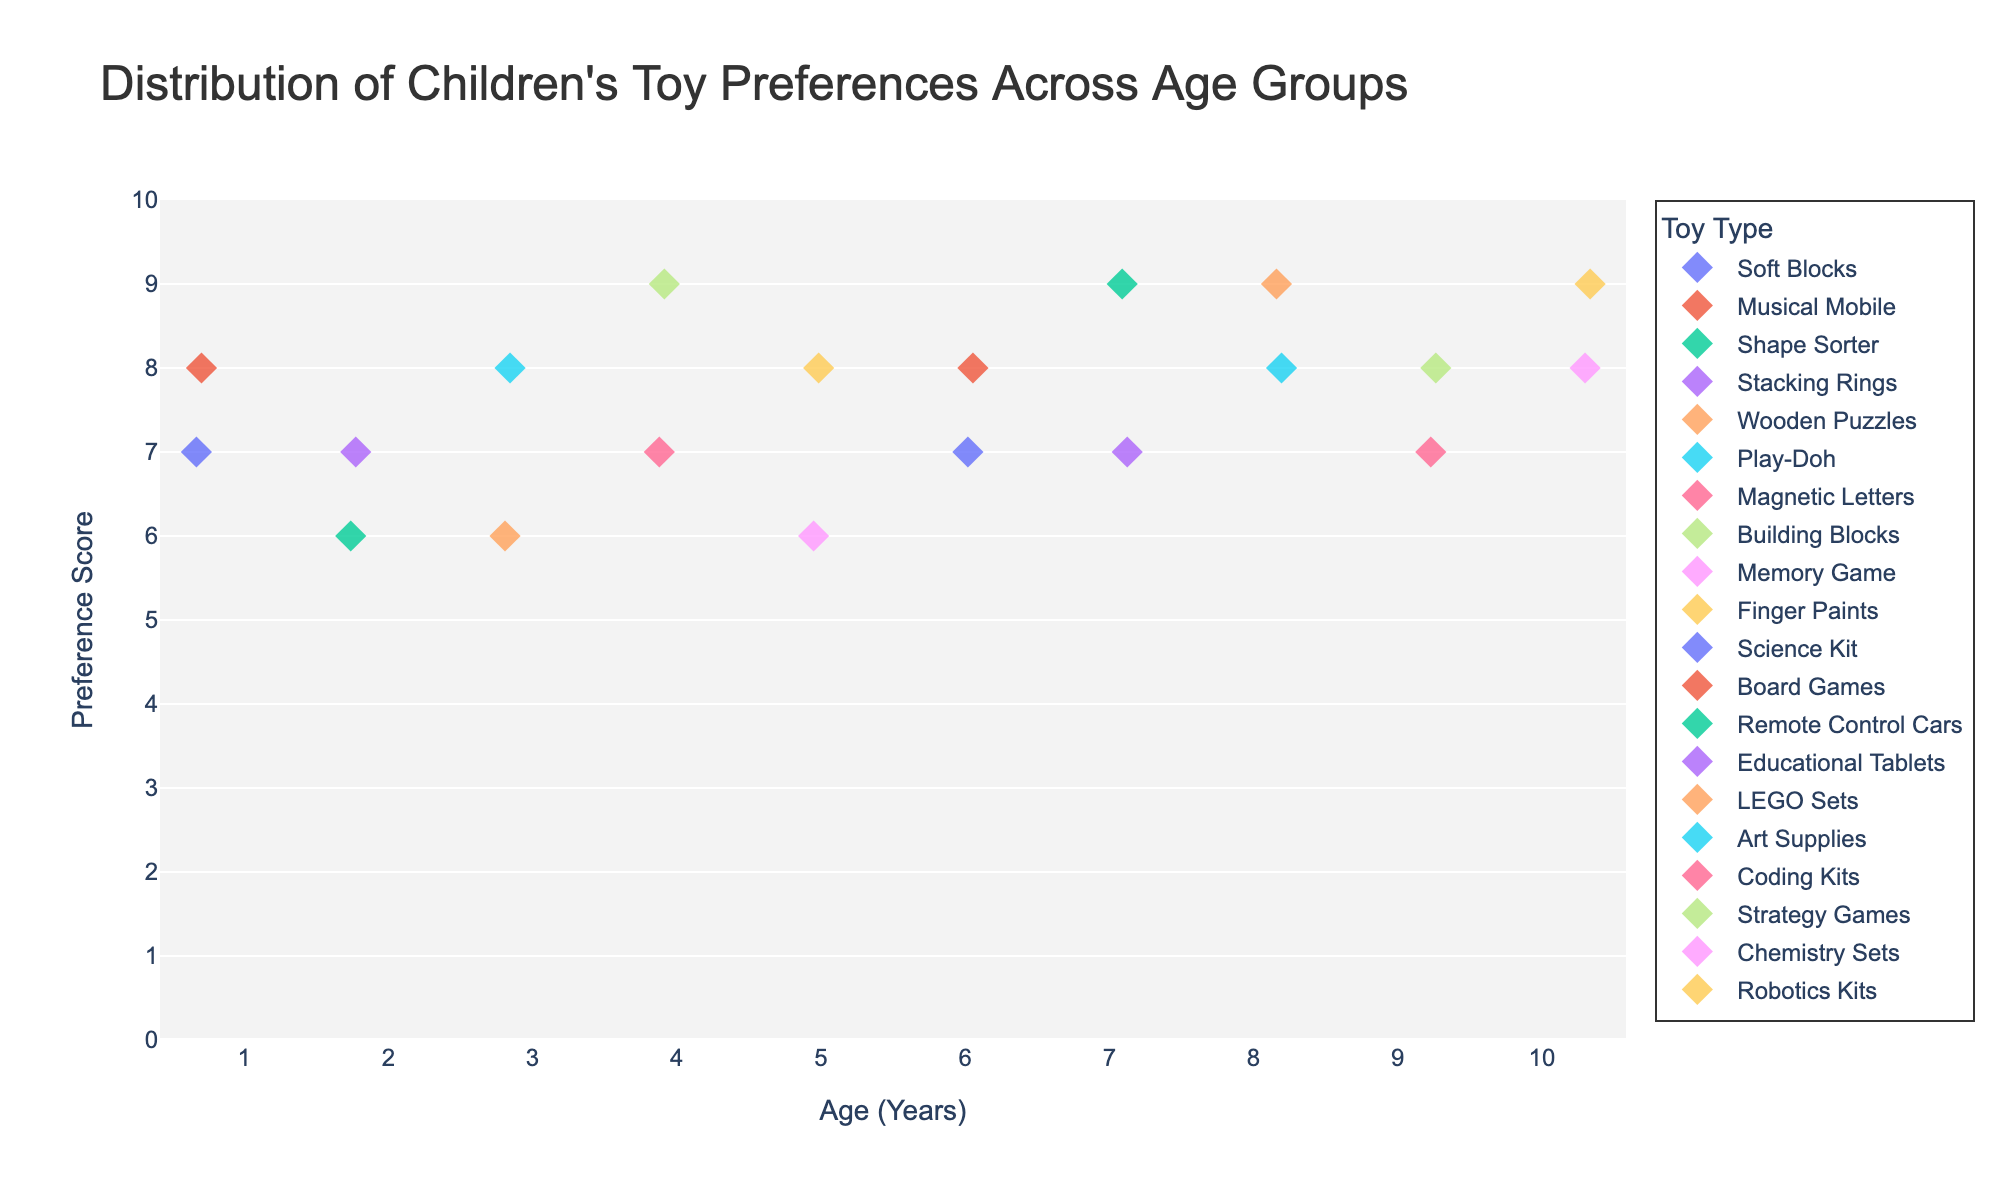What is the title of the plot? The title of a plot usually appears at the top and summarizes the content of the visual. In this case, it provides an overview of what the plot is about: the distribution of children's toy preferences across different age groups.
Answer: Distribution of Children's Toy Preferences Across Age Groups What is the range of the preference scores on the y-axis? The y-axis represents the preference scores, and by examining the plot, we can see that it ranges from the minimum value at the bottom to the maximum value at the top. According to the plot, the range is from 0 to 10.
Answer: 0 to 10 Which toy has the highest preference score for 4-year-olds? To answer this, look at the age group at 4 on the x-axis and identify the toy with the highest y-axis preference score within that subgroup. The toys for 4-year-olds are Magnetic Letters and Building Blocks, with Building Blocks having the highest preference score.
Answer: Building Blocks How many age groups have a preference score of 8 for any toy? To determine this, look for data points that are at a preference score of 8 on the y-axis and count the corresponding distinct age groups on the x-axis. There are six age groups (1, 3, 5, 6, 8, 10) with a preference score of 8 for some toy.
Answer: Six What is the average preference score for 7-year-olds? To find this, identify all the preference scores for 7-year-olds on the plot (which are 9 for Remote Control Cars and 7 for Educational Tablets). Calculate their average: (9 + 7) / 2 = 8.
Answer: 8 Which toy is preferred by 10-year-olds? Look at the data points for the age group 10 on the x-axis. The toys listed for 10-year-olds are Chemistry Sets and Robotics Kits.
Answer: Chemistry Sets, Robotics Kits What is the most preferred toy type for 8-year-olds? Locate the age group at 8 on the x-axis and identify which toy has the highest y-axis preference score. Both LEGO Sets and Art Supplies have high scores, with LEGO Sets having the highest (9).
Answer: LEGO Sets Between the age groups 2 and 6, which age group has the higher maximum preference score, and what is the value? Compare the highest preferences for both age groups. Age 2 has a maximum preference of 7 (Stacking Rings), and age 6 has a maximum of 8 (Board Games), so age 6 is higher.
Answer: Age 6, 8 How does the preference for Remote Control Cars compare to Coding Kits in terms of age groups? Find the preference scores for Remote Control Cars (age 7, score 9) and Coding Kits (age 9, score 7). Remote Control Cars have a higher score but for a younger age group.
Answer: Remote Control Cars: Higher preference (score 9 at age 7); Coding Kits: Lower preference (score 7 at age 9) Across all age groups, which toy has the overall highest recorded preference score and what is it? By observing the y-axis preference scores and identifying which toy corresponds to the highest score overall, you can see Building Blocks, Remote Control Cars, LEGO Sets, and Robotics Kits each have a score of 9.
Answer: Building Blocks, Remote Control Cars, LEGO Sets, Robotics Kits, 9 